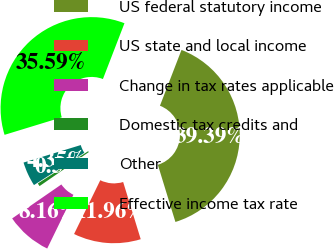Convert chart to OTSL. <chart><loc_0><loc_0><loc_500><loc_500><pie_chart><fcel>US federal statutory income<fcel>US state and local income<fcel>Change in tax rates applicable<fcel>Domestic tax credits and<fcel>Other<fcel>Effective income tax rate<nl><fcel>39.39%<fcel>11.96%<fcel>8.16%<fcel>0.55%<fcel>4.35%<fcel>35.59%<nl></chart> 